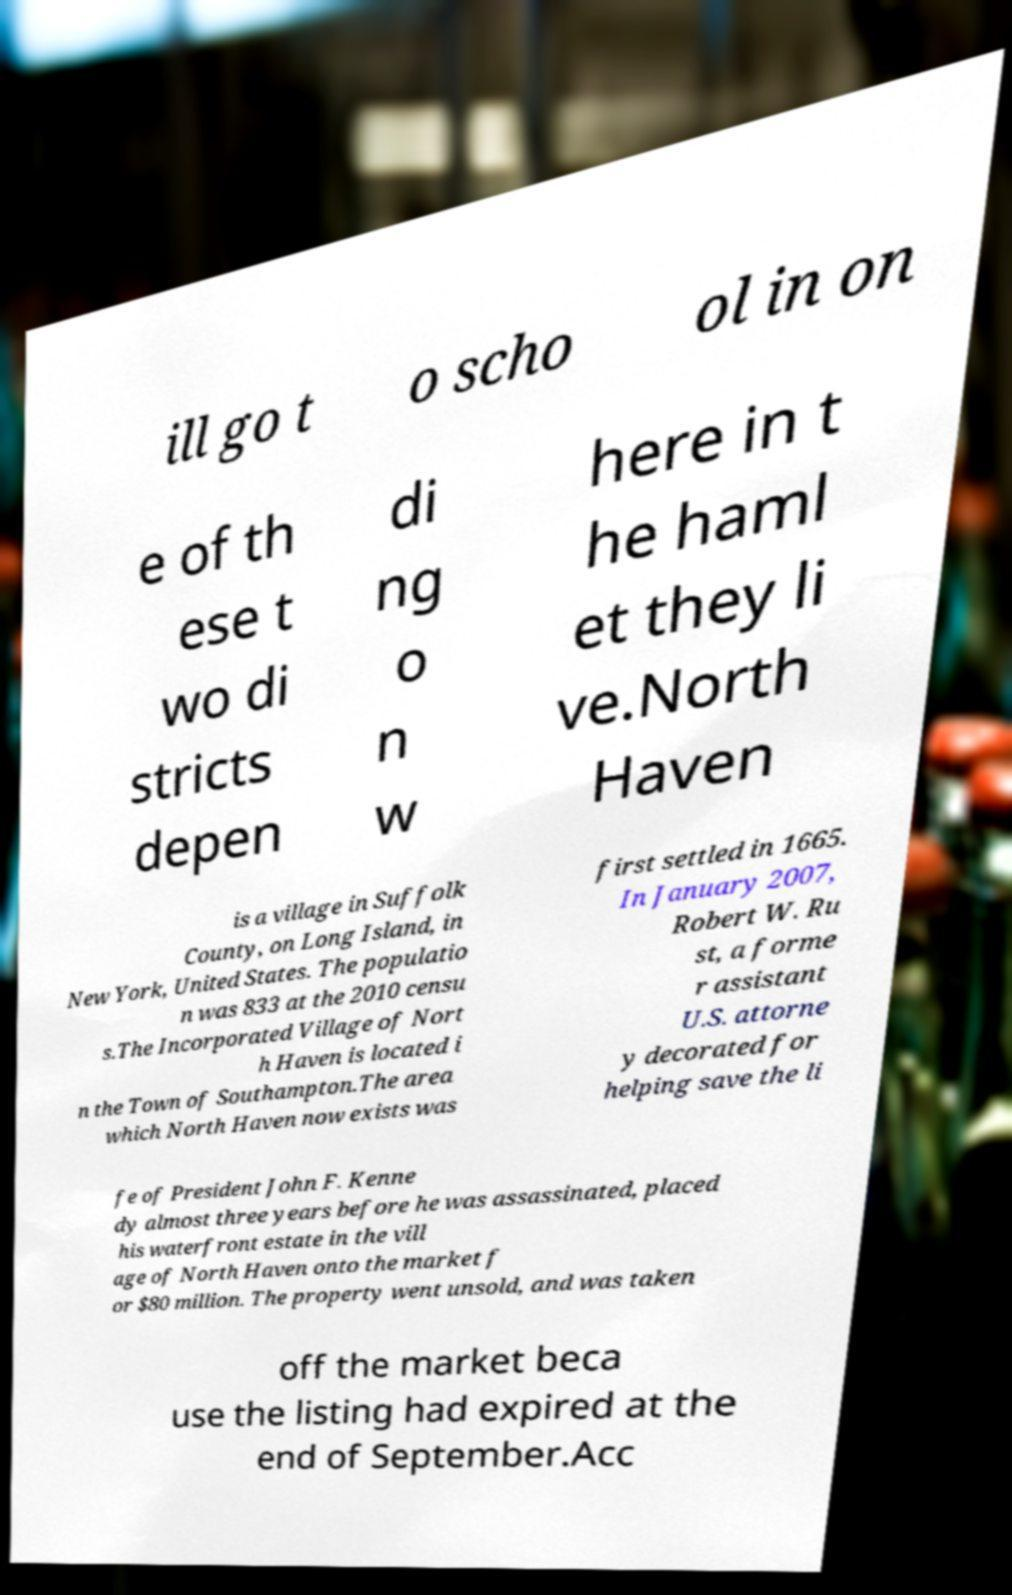Please read and relay the text visible in this image. What does it say? ill go t o scho ol in on e of th ese t wo di stricts depen di ng o n w here in t he haml et they li ve.North Haven is a village in Suffolk County, on Long Island, in New York, United States. The populatio n was 833 at the 2010 censu s.The Incorporated Village of Nort h Haven is located i n the Town of Southampton.The area which North Haven now exists was first settled in 1665. In January 2007, Robert W. Ru st, a forme r assistant U.S. attorne y decorated for helping save the li fe of President John F. Kenne dy almost three years before he was assassinated, placed his waterfront estate in the vill age of North Haven onto the market f or $80 million. The property went unsold, and was taken off the market beca use the listing had expired at the end of September.Acc 